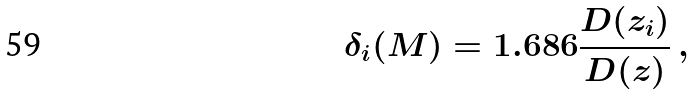Convert formula to latex. <formula><loc_0><loc_0><loc_500><loc_500>\delta _ { i } ( M ) = 1 . 6 8 6 \frac { D ( z _ { i } ) } { D ( z ) } \, ,</formula> 